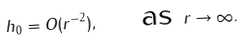<formula> <loc_0><loc_0><loc_500><loc_500>h _ { 0 } = O ( r ^ { - 2 } ) , \quad \text { as } r \to \infty .</formula> 